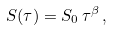<formula> <loc_0><loc_0><loc_500><loc_500>S ( \tau ) = S _ { 0 } \, \tau ^ { \beta } \, ,</formula> 